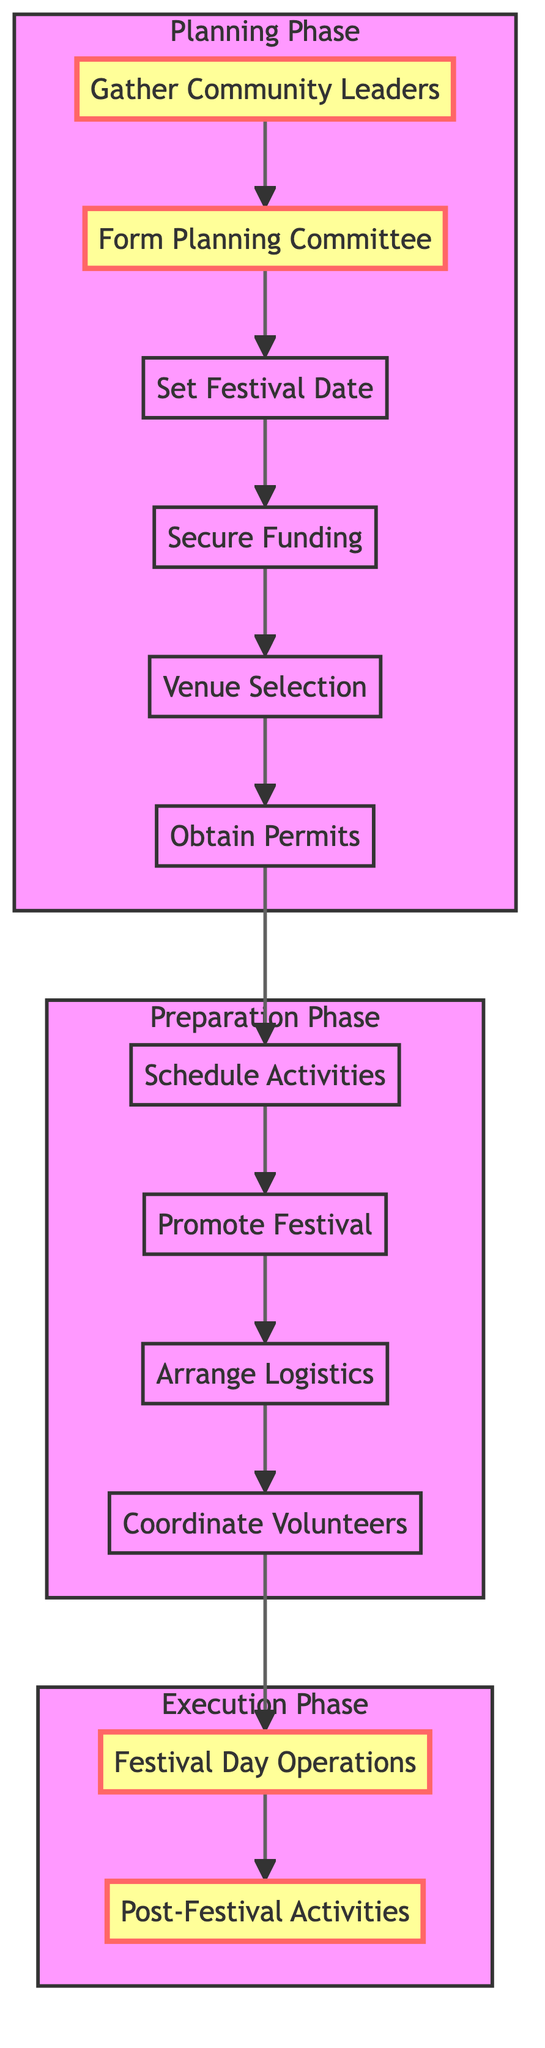What's the first activity in the diagram? The diagram starts with "Gather Community Leaders," which is the first node in the flow.
Answer: Gather Community Leaders How many activities are there in total? Counting all the activities listed in the diagram, there are 12 distinct activities involved in planning the festival.
Answer: 12 What activity follows "Secure Funding"? The next activity after "Secure Funding" is "Venue Selection," which is connected by a directed edge in the flow.
Answer: Venue Selection Which phase does "Promote Festival" belong to? "Promote Festival" is part of the "Preparation Phase," as it is included in the activities listed under that subgraph.
Answer: Preparation Phase What is the last activity depicted in the diagram? The last activity listed is "Post-Festival Activities," found at the end of the flow, following "Festival Day Operations."
Answer: Post-Festival Activities List an activity that precedes "Obtain Permits." The activity that comes before "Obtain Permits" is "Venue Selection," as seen in the sequential flow leading into it.
Answer: Venue Selection Which two phases are connected directly in the flow? The flow connects the "Planning Phase" directly to the "Preparation Phase," showing progression from one to the next.
Answer: Planning Phase and Preparation Phase What is the main purpose of the "Coordinate Volunteers" activity? This activity is aimed at organizing the volunteers for set-up, management, and clean-up for the festival, ensuring a smooth operation during the event.
Answer: Assign tasks What activity comes before "Festival Day Operations"? The activity "Coordinate Volunteers" directly precedes "Festival Day Operations," indicating preparation for the festival day itself.
Answer: Coordinate Volunteers How many phases are shown in the diagram? The diagram outlines three distinct phases: Planning Phase, Preparation Phase, and Execution Phase.
Answer: 3 